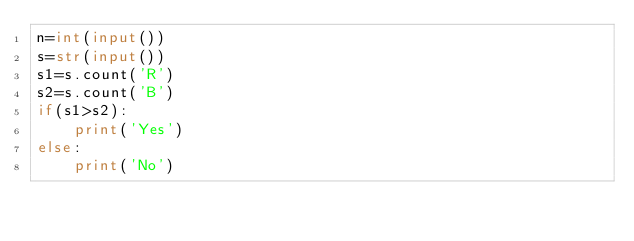<code> <loc_0><loc_0><loc_500><loc_500><_Python_>n=int(input())
s=str(input())
s1=s.count('R')
s2=s.count('B')
if(s1>s2):
    print('Yes')
else:
    print('No')
</code> 